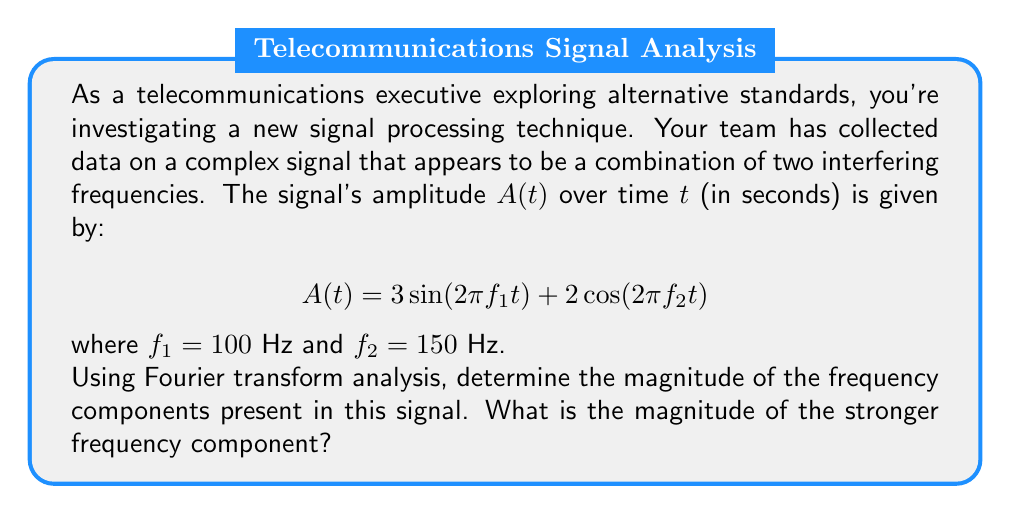What is the answer to this math problem? To solve this problem, we'll follow these steps:

1) The Fourier transform of a sinusoidal function is given by:
   $$\mathcal{F}\{a\sin(2\pi ft)\} = \frac{ai}{2}[\delta(f') - \delta(f'+f)]$$
   $$\mathcal{F}\{a\cos(2\pi ft)\} = \frac{a}{2}[\delta(f'-f) + \delta(f'+f)]$$

   Where $\delta$ is the Dirac delta function and $f'$ is the frequency variable in the Fourier domain.

2) For our signal, we have:
   $$A(t) = 3\sin(2\pi 100t) + 2\cos(2\pi 150t)$$

3) Taking the Fourier transform:
   $$\mathcal{F}\{A(t)\} = \frac{3i}{2}[\delta(f'-100) - \delta(f'+100)] + \frac{2}{2}[\delta(f'-150) + \delta(f'+150)]$$

4) The magnitude of each frequency component is given by the absolute value of its coefficient:
   For $f_1 = 100$ Hz: $|\frac{3i}{2}| = \frac{3}{2} = 1.5$
   For $f_2 = 150$ Hz: $|\frac{2}{2}| = 1$

5) The stronger frequency component has a magnitude of 1.5, corresponding to $f_1 = 100$ Hz.
Answer: 1.5 